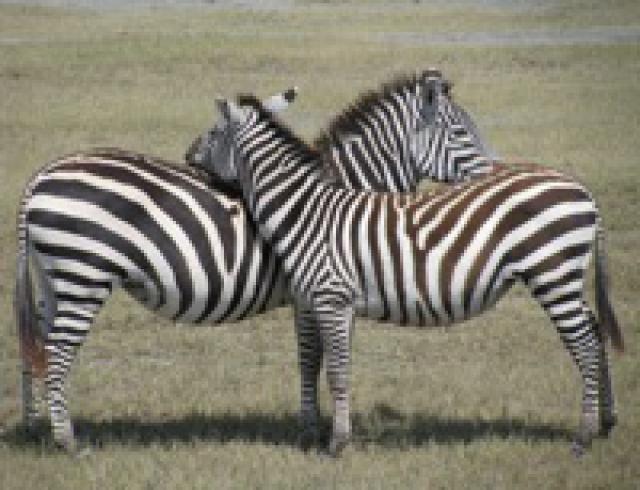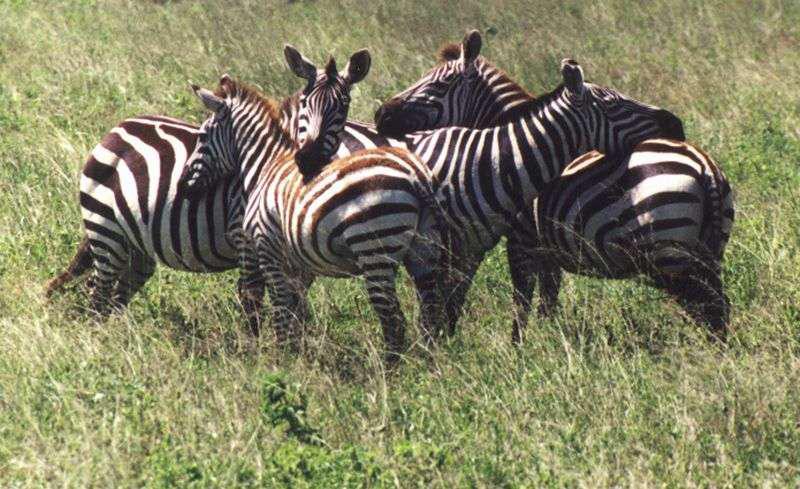The first image is the image on the left, the second image is the image on the right. Considering the images on both sides, is "The left and right image contains a total of five zebras." valid? Answer yes or no. No. The first image is the image on the left, the second image is the image on the right. Assess this claim about the two images: "Each image shows at least two zebra standing facing toward the center, one with its head over the back of the other.". Correct or not? Answer yes or no. Yes. 